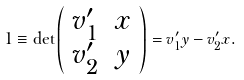<formula> <loc_0><loc_0><loc_500><loc_500>1 \equiv \det \left ( \begin{array} { c c } v _ { 1 } ^ { \prime } & x \\ v _ { 2 } ^ { \prime } & y \end{array} \right ) = v _ { 1 } ^ { \prime } y - v _ { 2 } ^ { \prime } x .</formula> 